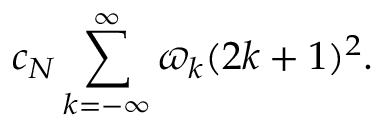<formula> <loc_0><loc_0><loc_500><loc_500>c _ { N } \sum _ { k = - \infty } ^ { \infty } \varpi _ { k } ( 2 k + 1 ) ^ { 2 } .</formula> 